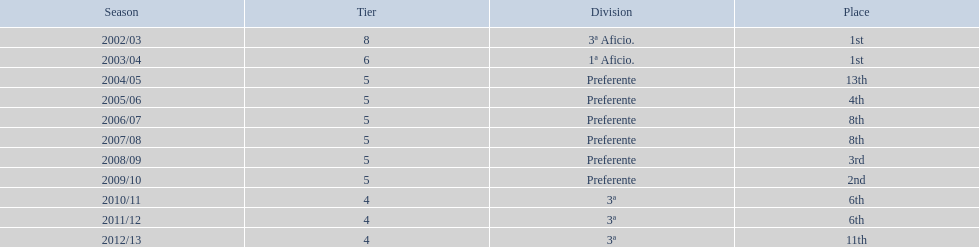I'm looking to parse the entire table for insights. Could you assist me with that? {'header': ['Season', 'Tier', 'Division', 'Place'], 'rows': [['2002/03', '8', '3ª Aficio.', '1st'], ['2003/04', '6', '1ª Aficio.', '1st'], ['2004/05', '5', 'Preferente', '13th'], ['2005/06', '5', 'Preferente', '4th'], ['2006/07', '5', 'Preferente', '8th'], ['2007/08', '5', 'Preferente', '8th'], ['2008/09', '5', 'Preferente', '3rd'], ['2009/10', '5', 'Preferente', '2nd'], ['2010/11', '4', '3ª', '6th'], ['2011/12', '4', '3ª', '6th'], ['2012/13', '4', '3ª', '11th']]} Which section has the highest number of levels? Preferente. 